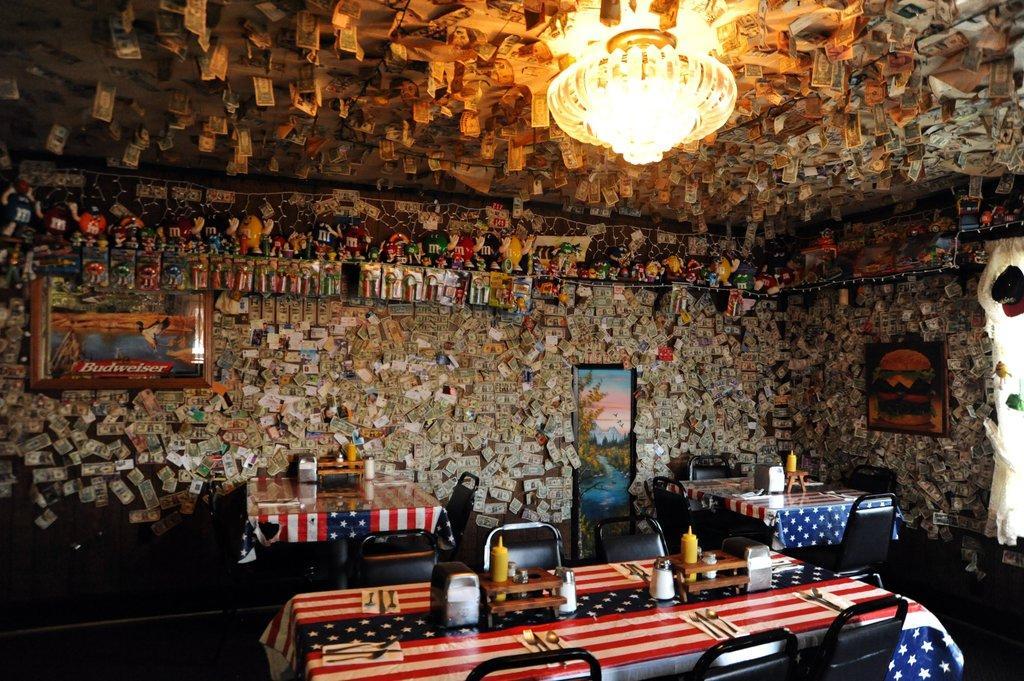In one or two sentences, can you explain what this image depicts? In this picture I can see the chairs, dining tables and bottles. In the background there are photo frames and other images on the wall. At the top I can see the light. 